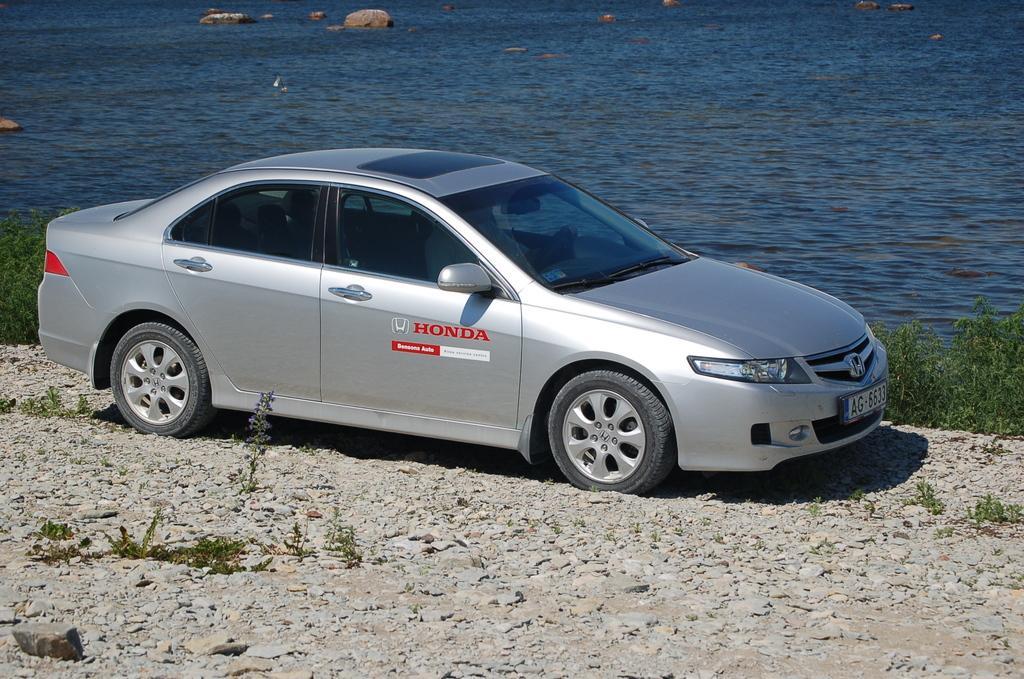Could you give a brief overview of what you see in this image? We can see car on the surface, stones and plants. In the background we can see water and rocks. 